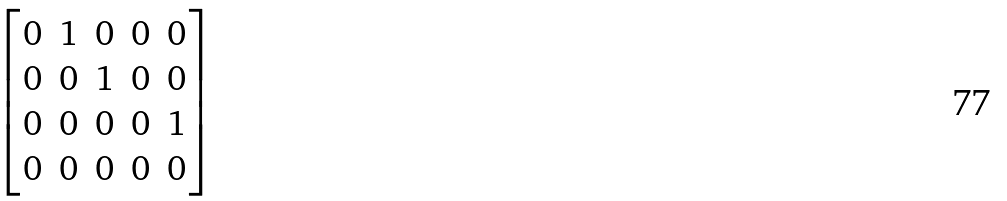Convert formula to latex. <formula><loc_0><loc_0><loc_500><loc_500>\begin{bmatrix} 0 & 1 & 0 & 0 & 0 \\ 0 & 0 & 1 & 0 & 0 \\ 0 & 0 & 0 & 0 & 1 \\ 0 & 0 & 0 & 0 & 0 \end{bmatrix}</formula> 